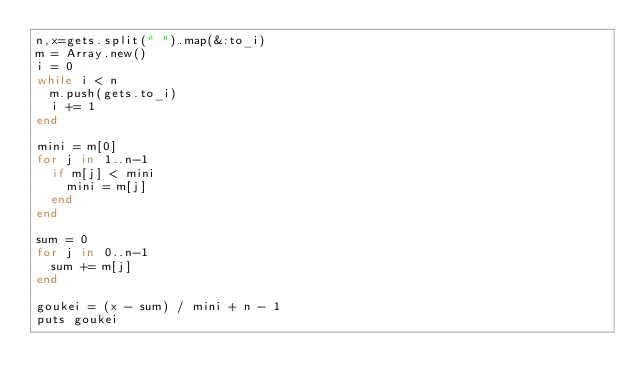<code> <loc_0><loc_0><loc_500><loc_500><_Ruby_>n,x=gets.split(" ").map(&:to_i)
m = Array.new()
i = 0
while i < n
  m.push(gets.to_i)
  i += 1
end

mini = m[0]
for j in 1..n-1
  if m[j] < mini
    mini = m[j]
  end
end

sum = 0
for j in 0..n-1
  sum += m[j]
end

goukei = (x - sum) / mini + n - 1
puts goukei
</code> 